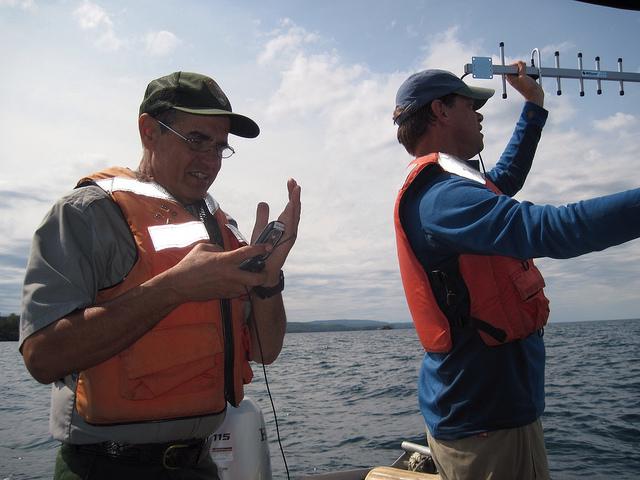What is the man holding in his hand?
Write a very short answer. Antenna. Is the man holding metal?
Write a very short answer. Yes. What is the orange thing on the men?
Answer briefly. Life jackets. Are these men on a boat?
Answer briefly. Yes. Is the man in the forefront trying to get signal on a cell phone?
Answer briefly. Yes. 